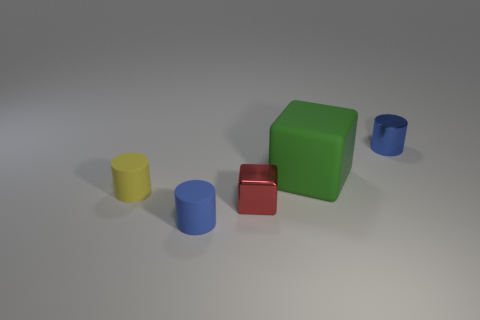Add 3 cylinders. How many objects exist? 8 Subtract all cylinders. How many objects are left? 2 Subtract all small brown metal cubes. Subtract all large objects. How many objects are left? 4 Add 3 tiny red things. How many tiny red things are left? 4 Add 4 small red objects. How many small red objects exist? 5 Subtract 0 brown blocks. How many objects are left? 5 